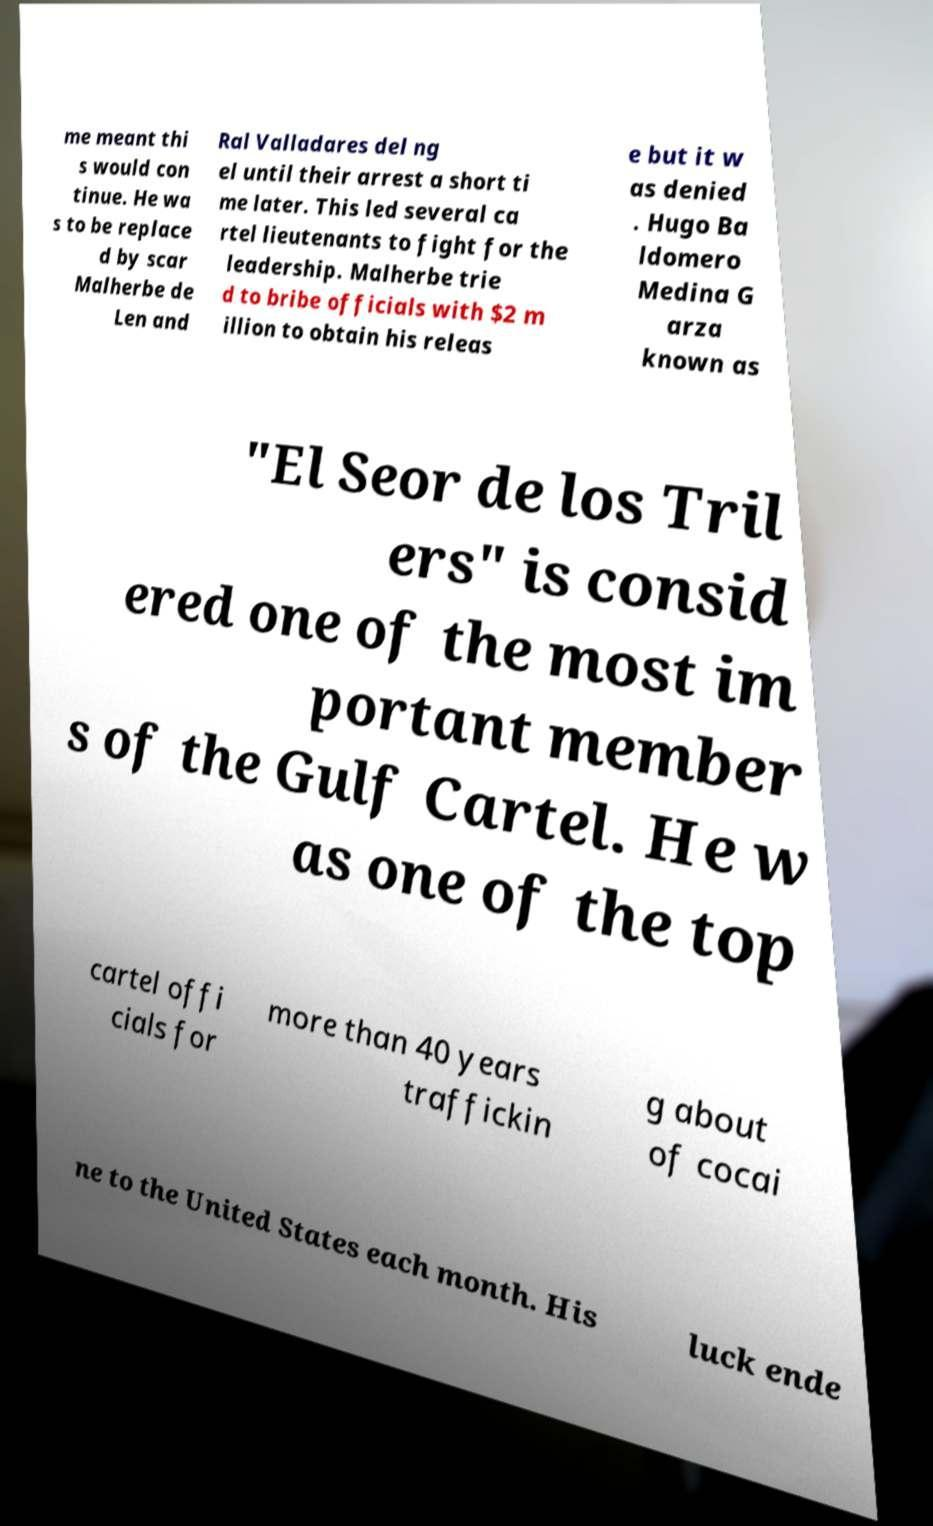What messages or text are displayed in this image? I need them in a readable, typed format. me meant thi s would con tinue. He wa s to be replace d by scar Malherbe de Len and Ral Valladares del ng el until their arrest a short ti me later. This led several ca rtel lieutenants to fight for the leadership. Malherbe trie d to bribe officials with $2 m illion to obtain his releas e but it w as denied . Hugo Ba ldomero Medina G arza known as "El Seor de los Tril ers" is consid ered one of the most im portant member s of the Gulf Cartel. He w as one of the top cartel offi cials for more than 40 years traffickin g about of cocai ne to the United States each month. His luck ende 